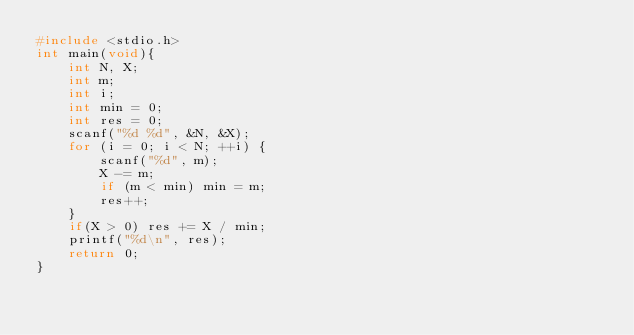Convert code to text. <code><loc_0><loc_0><loc_500><loc_500><_C_>#include <stdio.h>
int main(void){
    int N, X;
    int m;
    int i;
    int min = 0;
    int res = 0;
    scanf("%d %d", &N, &X);
    for (i = 0; i < N; ++i) {
        scanf("%d", m);
        X -= m;
        if (m < min) min = m;
        res++;
    }
    if(X > 0) res += X / min;
    printf("%d\n", res);
    return 0;
}
</code> 